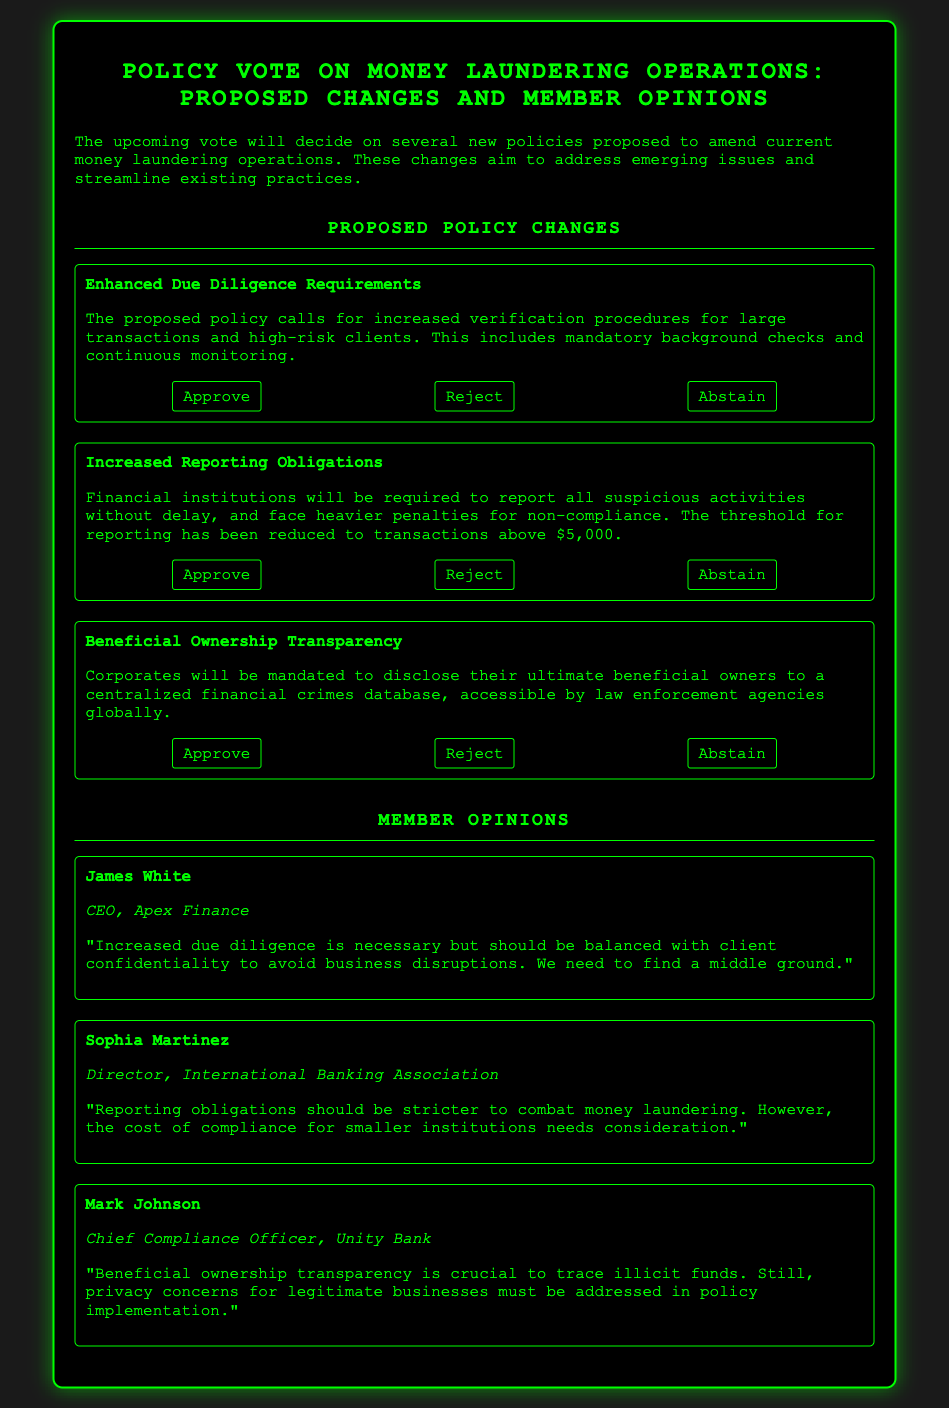What is the title of the ballot? The title of the ballot is prominently displayed in a header and reads "Policy Vote on Money Laundering Operations: Proposed Changes and Member Opinions."
Answer: Policy Vote on Money Laundering Operations: Proposed Changes and Member Opinions What is the threshold for reporting suspicious activities? The threshold for reporting suspicious activities has been stated in the document as being reduced to transactions above $5,000.
Answer: $5,000 Who is the CEO of Apex Finance? The document provides member opinions, and one of them is from James White, who is identified as the CEO of Apex Finance.
Answer: James White What is the opinion of Mark Johnson regarding beneficial ownership transparency? Mark Johnson's opinion is stated in the document that beneficial ownership transparency is crucial to trace illicit funds but that privacy concerns must be addressed.
Answer: Crucial to trace illicit funds What are the three proposed policies mentioned in the document? The three proposed policies outlined in the document are Enhanced Due Diligence Requirements, Increased Reporting Obligations, and Beneficial Ownership Transparency.
Answer: Enhanced Due Diligence Requirements, Increased Reporting Obligations, Beneficial Ownership Transparency What is Sophia Martinez's role? Sophia Martinez's role is indicated in the member opinions section, where she is identified as the Director of the International Banking Association.
Answer: Director, International Banking Association What is the stance of James White on increased due diligence? James White expresses a need for increased due diligence while suggesting it should be balanced with client confidentiality to avoid disruptions.
Answer: Necessary but should be balanced with client confidentiality What type of document is this? The document is a structured format that presents proposed policies and member opinions related to those policies in a voting context.
Answer: Ballot 